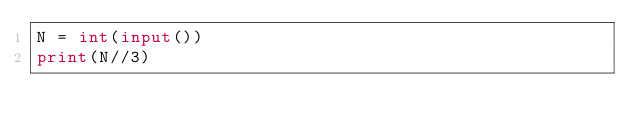<code> <loc_0><loc_0><loc_500><loc_500><_Python_>N = int(input())
print(N//3)</code> 